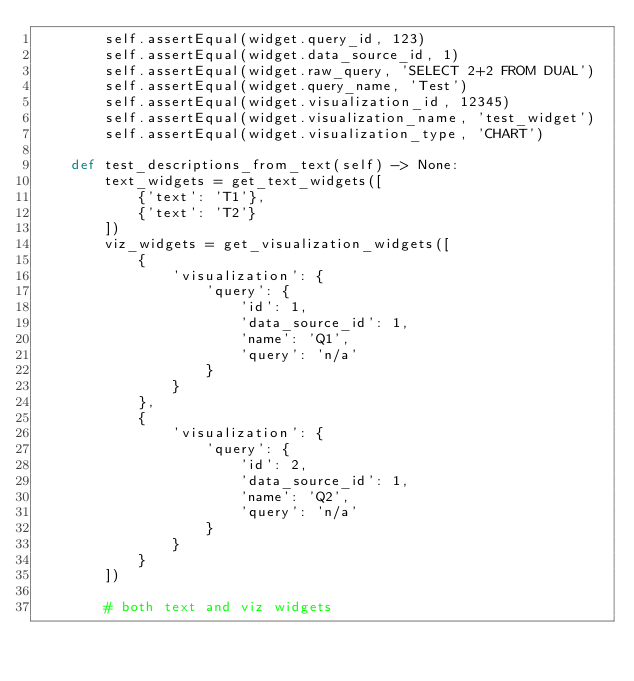Convert code to text. <code><loc_0><loc_0><loc_500><loc_500><_Python_>        self.assertEqual(widget.query_id, 123)
        self.assertEqual(widget.data_source_id, 1)
        self.assertEqual(widget.raw_query, 'SELECT 2+2 FROM DUAL')
        self.assertEqual(widget.query_name, 'Test')
        self.assertEqual(widget.visualization_id, 12345)
        self.assertEqual(widget.visualization_name, 'test_widget')
        self.assertEqual(widget.visualization_type, 'CHART')

    def test_descriptions_from_text(self) -> None:
        text_widgets = get_text_widgets([
            {'text': 'T1'},
            {'text': 'T2'}
        ])
        viz_widgets = get_visualization_widgets([
            {
                'visualization': {
                    'query': {
                        'id': 1,
                        'data_source_id': 1,
                        'name': 'Q1',
                        'query': 'n/a'
                    }
                }
            },
            {
                'visualization': {
                    'query': {
                        'id': 2,
                        'data_source_id': 1,
                        'name': 'Q2',
                        'query': 'n/a'
                    }
                }
            }
        ])

        # both text and viz widgets</code> 